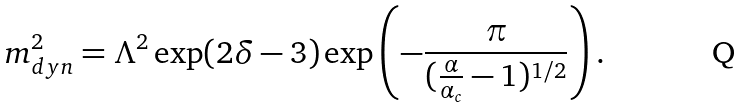<formula> <loc_0><loc_0><loc_500><loc_500>m _ { d y n } ^ { 2 } = \Lambda ^ { 2 } \exp ( 2 \delta - 3 ) \exp \left ( - \frac { \pi } { ( \frac { \alpha } { \alpha _ { c } } - 1 ) ^ { 1 / 2 } } \right ) .</formula> 